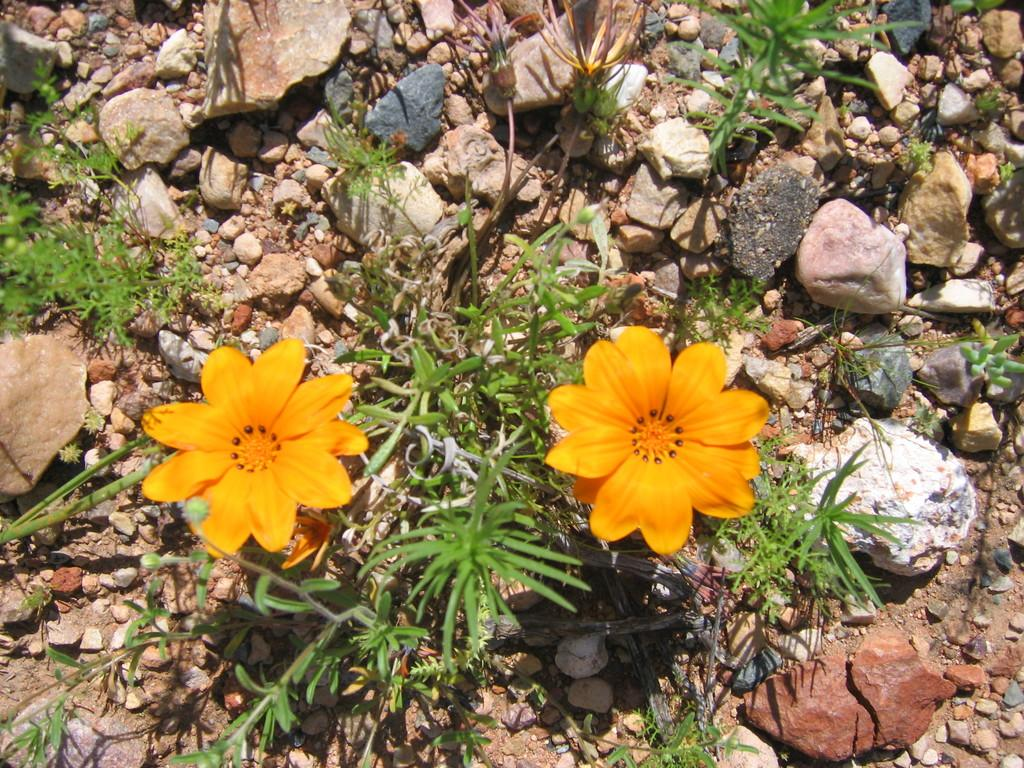What type of living organisms can be seen in the image? Plants and flowers are visible in the image. What other objects can be seen in the image besides plants and flowers? There are stones in the image. What type of glass can be seen in the image? There is no glass present in the image. What are the hands doing in the image? There are no hands visible in the image. 